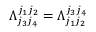Convert formula to latex. <formula><loc_0><loc_0><loc_500><loc_500>\Lambda _ { j _ { 3 } j _ { 4 } } ^ { j _ { 1 } j _ { 2 } } = \Lambda _ { j _ { 1 } j _ { 2 } } ^ { j _ { 3 } j _ { 4 } }</formula> 